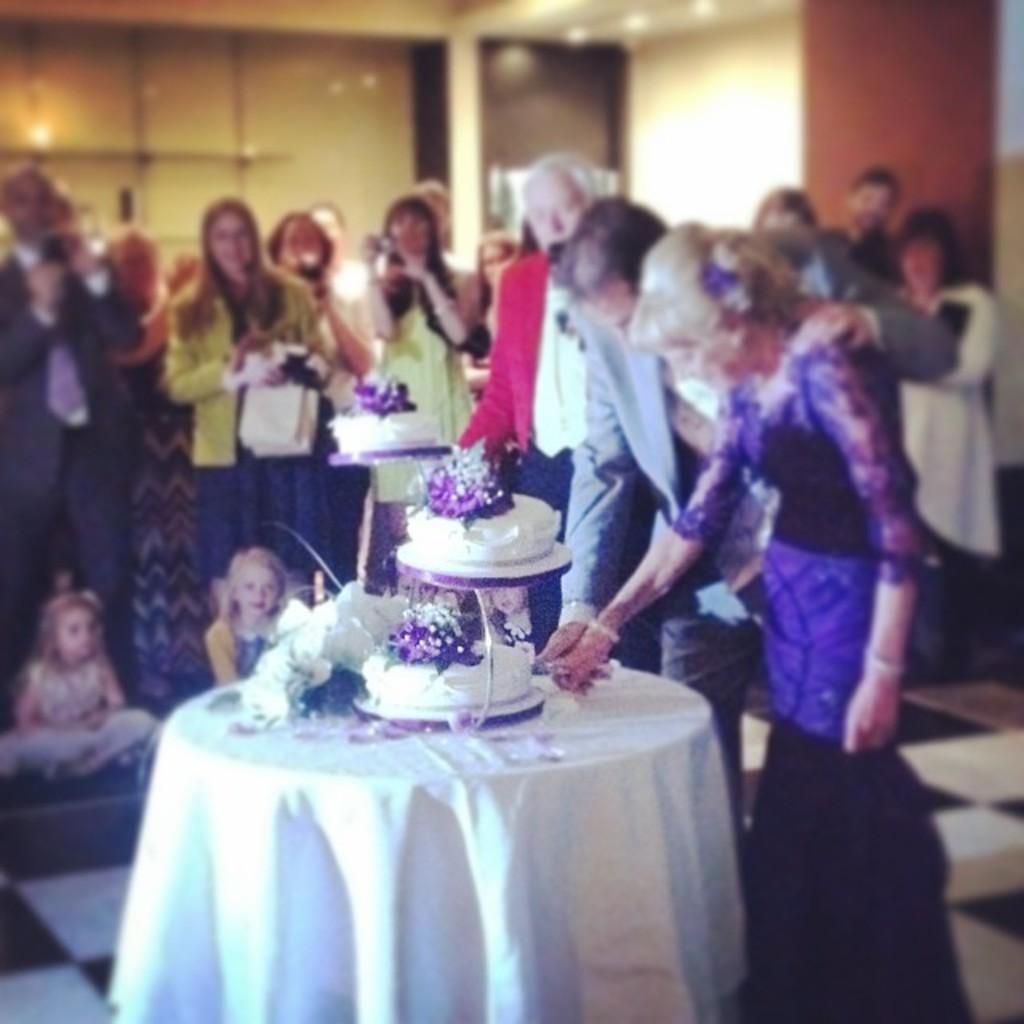In one or two sentences, can you explain what this image depicts? In this image i can see a man and woman cutting cake on table at the background i can see few other man standing, a glass and a wall. 